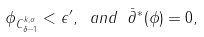Convert formula to latex. <formula><loc_0><loc_0><loc_500><loc_500>\| \phi \| _ { C ^ { k , \alpha } _ { \delta - 1 } } < \epsilon ^ { \prime } , \ a n d \ \bar { \partial } ^ { * } ( \phi ) = 0 ,</formula> 